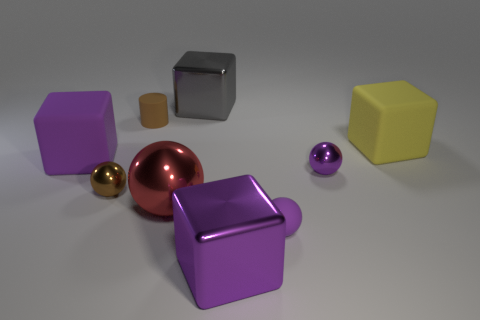What color is the tiny rubber object that is behind the large purple thing that is behind the purple block on the right side of the red metallic object?
Provide a succinct answer. Brown. How many brown objects have the same size as the brown metal ball?
Offer a very short reply. 1. What is the color of the rubber block that is in front of the big yellow matte object?
Provide a succinct answer. Purple. What number of other things are there of the same size as the gray block?
Keep it short and to the point. 4. There is a purple object that is to the right of the small brown metal object and behind the large ball; what is its size?
Your answer should be very brief. Small. There is a large sphere; is its color the same as the big rubber block right of the tiny brown sphere?
Give a very brief answer. No. Are there any big red metallic things of the same shape as the yellow matte object?
Your answer should be very brief. No. How many things are big brown rubber balls or matte things that are in front of the tiny rubber cylinder?
Your answer should be very brief. 3. How many other things are the same material as the red thing?
Offer a very short reply. 4. What number of objects are either big metallic objects or large blocks?
Keep it short and to the point. 5. 